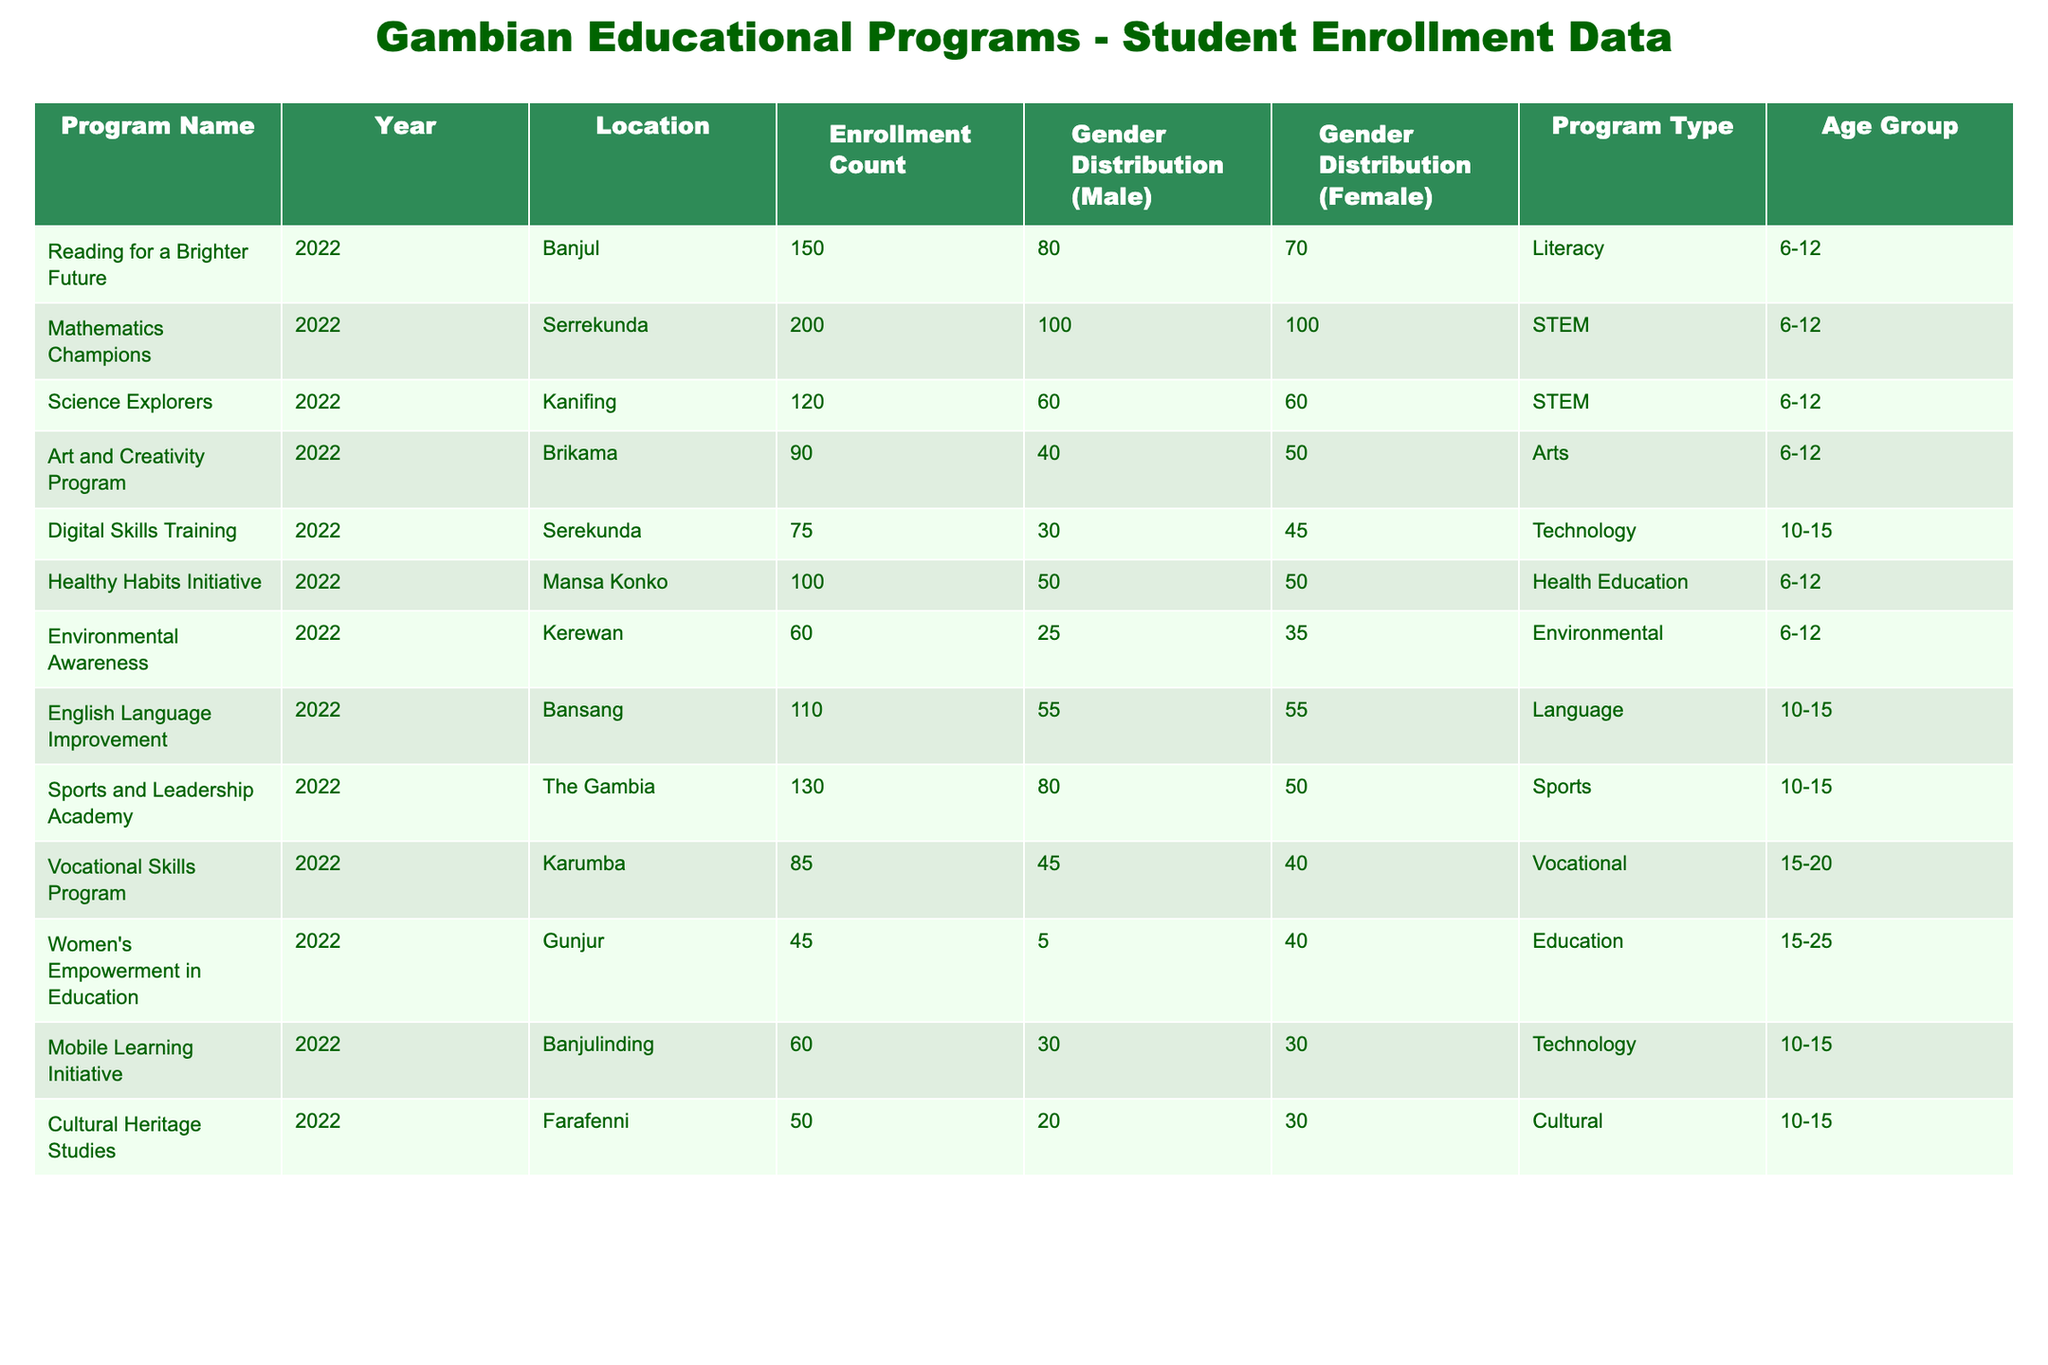What is the enrollment count for the “Reading for a Brighter Future” program? The enrollment count for this program is specifically stated in the table. Looking under the "Enrollment Count" column corresponding to the "Reading for a Brighter Future" row, we find 150.
Answer: 150 What is the gender distribution for the "Women's Empowerment in Education" program? By locating the "Women's Empowerment in Education" row, we see the "Gender Distribution (Male)" shows 5 and "Gender Distribution (Female)" shows 40.
Answer: Male: 5, Female: 40 Which educational program had the highest enrollment count? To determine this, we compare all the "Enrollment Count" values in the table. The highest count is from the "Mathematics Champions" program with 200.
Answer: Mathematics Champions What is the total enrollment count for all programs in 2022? We sum the "Enrollment Count" values of all programs listed in the table: 150 + 200 + 120 + 90 + 75 + 100 + 60 + 110 + 130 + 85 + 45 + 60 + 50 = 1,225. The total enrollment count is 1,225.
Answer: 1225 Does the “Digital Skills Training” program enroll more females than males? Checking the "Digital Skills Training" program, the gender distribution shows 30 males and 45 females. Since 45 is greater than 30, the statement is true.
Answer: Yes Which program has the lowest enrollment count and what is that count? By inspecting the "Enrollment Count" column, the "Cultural Heritage Studies" program shows the lowest count at 50.
Answer: 50 Is the average enrollment for STEM programs greater than for Arts programs? First, calculate the total for STEM programs: 200 (Mathematics Champions) + 120 (Science Explorers) = 320, and the number of STEM programs is 2, so the average is 320/2 = 160. For Arts, it's 90 (Art and Creativity Program), and thus the average is 90/1 = 90. Since 160 is greater than 90, the statement is true.
Answer: Yes Which location had the highest enrollment in a program for children aged 6-12? Analyzing the programs for age group 6-12, we see "Mathematics Champions" in “Serrekunda” has the highest enrollment at 200.
Answer: Serrekunda How many total female students are enrolled in programs focused on technology? The programs focused on technology are "Digital Skills Training" (45 females) and "Mobile Learning Initiative" (30 females). Adding these gives 45 + 30 = 75 total females in technology programs.
Answer: 75 